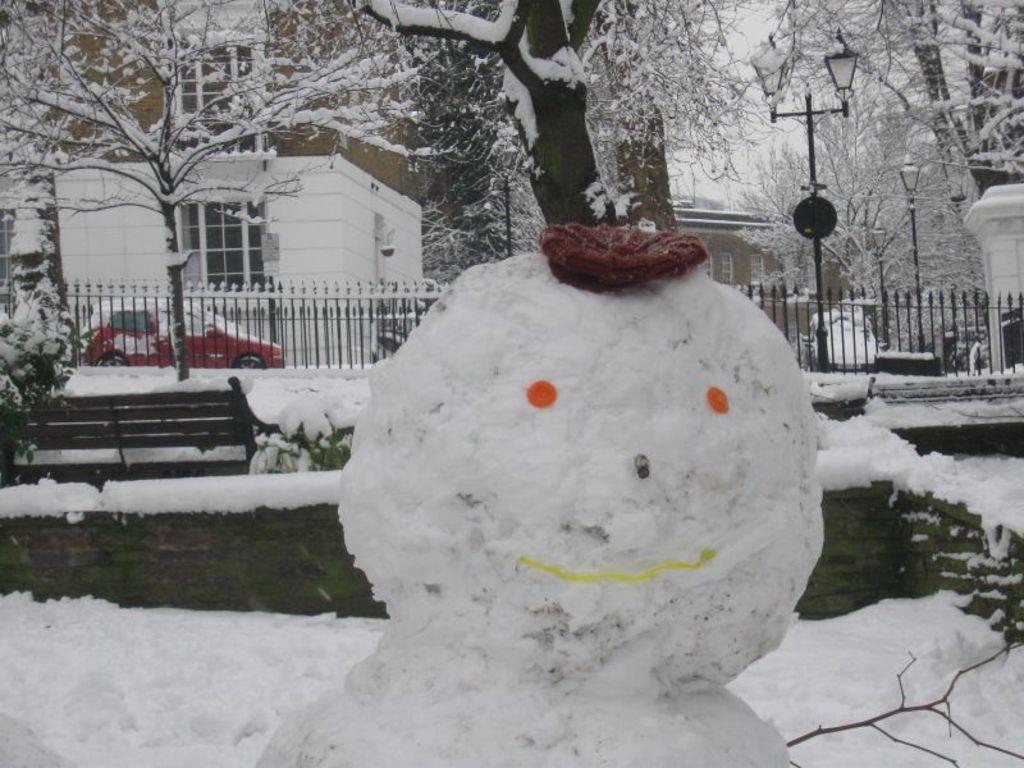Could you give a brief overview of what you see in this image? In this image, we can see a snowman with a cap. In the background, we can see the plants, bench, snow, fences, vehicle, buildings, trees, street lights, walls and glass objects.  